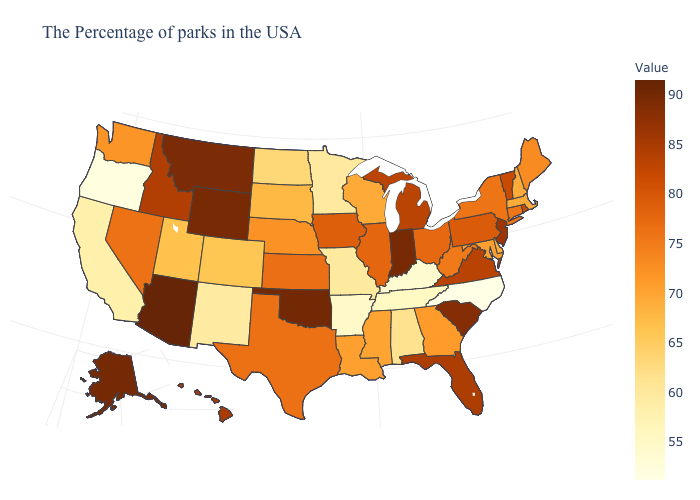Does Arizona have the highest value in the USA?
Keep it brief. Yes. Does Ohio have the highest value in the MidWest?
Be succinct. No. Which states have the lowest value in the USA?
Short answer required. North Carolina. Which states have the lowest value in the USA?
Write a very short answer. North Carolina. Does Hawaii have a higher value than Maryland?
Concise answer only. Yes. Does Massachusetts have the highest value in the Northeast?
Keep it brief. No. 